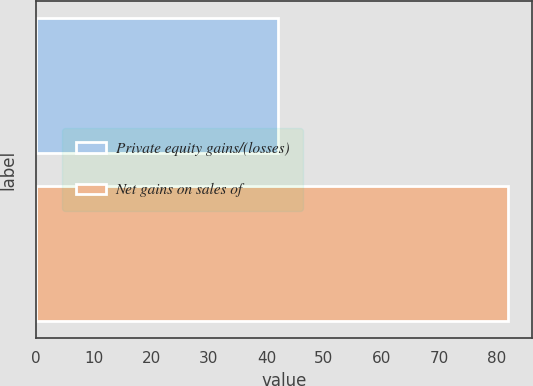Convert chart to OTSL. <chart><loc_0><loc_0><loc_500><loc_500><bar_chart><fcel>Private equity gains/(losses)<fcel>Net gains on sales of<nl><fcel>42<fcel>82<nl></chart> 